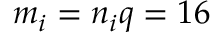<formula> <loc_0><loc_0><loc_500><loc_500>m _ { i } = n _ { i } q = 1 6</formula> 